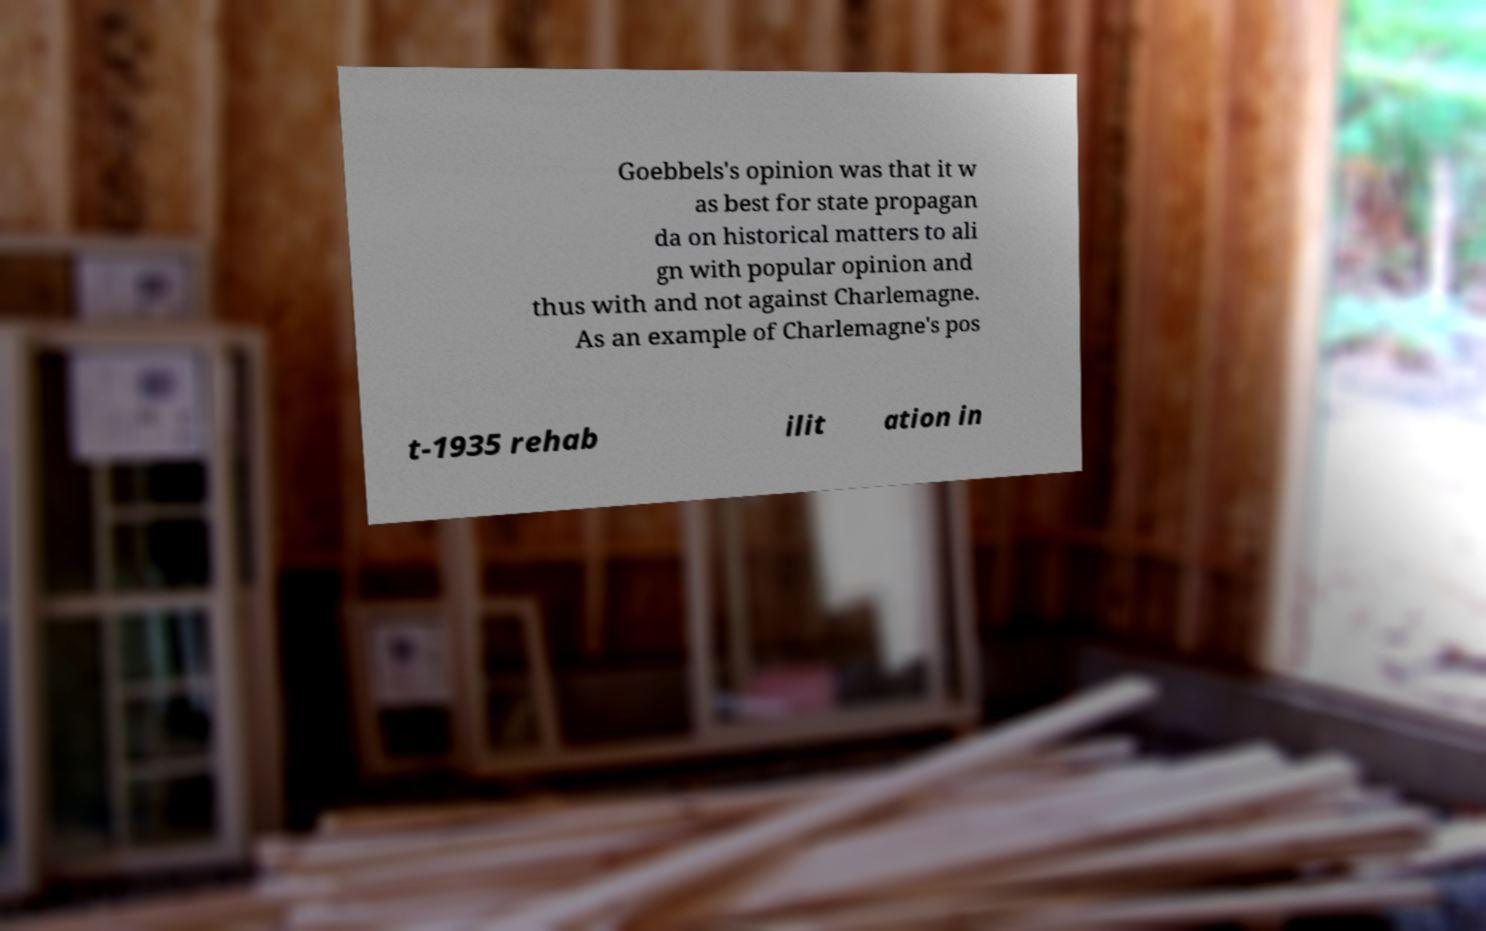Please identify and transcribe the text found in this image. Goebbels's opinion was that it w as best for state propagan da on historical matters to ali gn with popular opinion and thus with and not against Charlemagne. As an example of Charlemagne's pos t-1935 rehab ilit ation in 